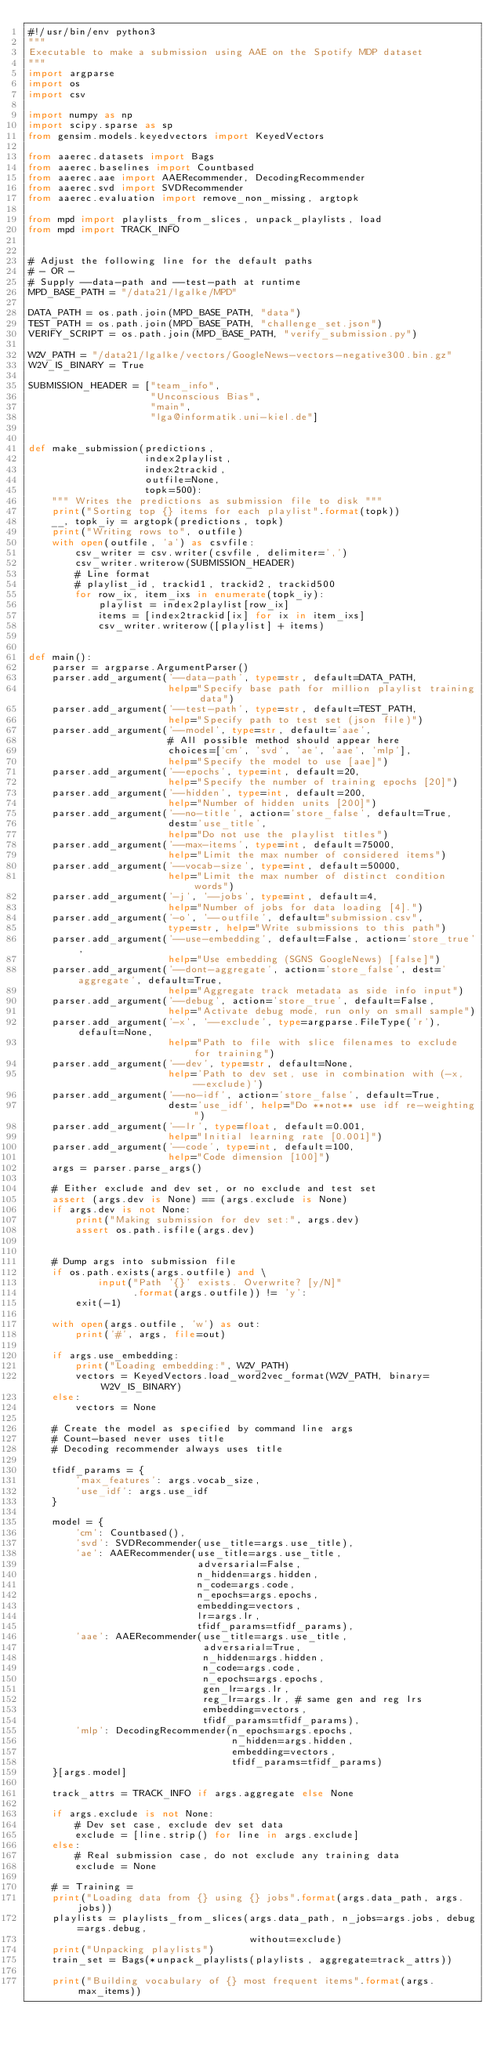<code> <loc_0><loc_0><loc_500><loc_500><_Python_>#!/usr/bin/env python3
"""
Executable to make a submission using AAE on the Spotify MDP dataset
"""
import argparse
import os
import csv

import numpy as np
import scipy.sparse as sp
from gensim.models.keyedvectors import KeyedVectors

from aaerec.datasets import Bags
from aaerec.baselines import Countbased
from aaerec.aae import AAERecommender, DecodingRecommender
from aaerec.svd import SVDRecommender
from aaerec.evaluation import remove_non_missing, argtopk

from mpd import playlists_from_slices, unpack_playlists, load
from mpd import TRACK_INFO


# Adjust the following line for the default paths
# - OR -
# Supply --data-path and --test-path at runtime
MPD_BASE_PATH = "/data21/lgalke/MPD"

DATA_PATH = os.path.join(MPD_BASE_PATH, "data")
TEST_PATH = os.path.join(MPD_BASE_PATH, "challenge_set.json")
VERIFY_SCRIPT = os.path.join(MPD_BASE_PATH, "verify_submission.py")

W2V_PATH = "/data21/lgalke/vectors/GoogleNews-vectors-negative300.bin.gz"
W2V_IS_BINARY = True

SUBMISSION_HEADER = ["team_info",
                     "Unconscious Bias",
                     "main",
                     "lga@informatik.uni-kiel.de"]


def make_submission(predictions,
                    index2playlist,
                    index2trackid,
                    outfile=None,
                    topk=500):
    """ Writes the predictions as submission file to disk """
    print("Sorting top {} items for each playlist".format(topk))
    __, topk_iy = argtopk(predictions, topk)
    print("Writing rows to", outfile)
    with open(outfile, 'a') as csvfile:
        csv_writer = csv.writer(csvfile, delimiter=',')
        csv_writer.writerow(SUBMISSION_HEADER)
        # Line format
        # playlist_id, trackid1, trackid2, trackid500
        for row_ix, item_ixs in enumerate(topk_iy):
            playlist = index2playlist[row_ix]
            items = [index2trackid[ix] for ix in item_ixs]
            csv_writer.writerow([playlist] + items)


def main():
    parser = argparse.ArgumentParser()
    parser.add_argument('--data-path', type=str, default=DATA_PATH,
                        help="Specify base path for million playlist training data")
    parser.add_argument('--test-path', type=str, default=TEST_PATH,
                        help="Specify path to test set (json file)")
    parser.add_argument('--model', type=str, default='aae',
                        # All possible method should appear here
                        choices=['cm', 'svd', 'ae', 'aae', 'mlp'],
                        help="Specify the model to use [aae]")
    parser.add_argument('--epochs', type=int, default=20,
                        help="Specify the number of training epochs [20]")
    parser.add_argument('--hidden', type=int, default=200,
                        help="Number of hidden units [200]")
    parser.add_argument('--no-title', action='store_false', default=True,
                        dest='use_title',
                        help="Do not use the playlist titles")
    parser.add_argument('--max-items', type=int, default=75000,
                        help="Limit the max number of considered items")
    parser.add_argument('--vocab-size', type=int, default=50000,
                        help="Limit the max number of distinct condition words")
    parser.add_argument('-j', '--jobs', type=int, default=4,
                        help="Number of jobs for data loading [4].")
    parser.add_argument('-o', '--outfile', default="submission.csv",
                        type=str, help="Write submissions to this path")
    parser.add_argument('--use-embedding', default=False, action='store_true',
                        help="Use embedding (SGNS GoogleNews) [false]")
    parser.add_argument('--dont-aggregate', action='store_false', dest='aggregate', default=True,
                        help="Aggregate track metadata as side info input")
    parser.add_argument('--debug', action='store_true', default=False,
                        help="Activate debug mode, run only on small sample")
    parser.add_argument('-x', '--exclude', type=argparse.FileType('r'),  default=None,
                        help="Path to file with slice filenames to exclude for training")
    parser.add_argument('--dev', type=str, default=None,
                        help='Path to dev set, use in combination with (-x, --exclude)')
    parser.add_argument('--no-idf', action='store_false', default=True,
                        dest='use_idf', help="Do **not** use idf re-weighting")
    parser.add_argument('--lr', type=float, default=0.001,
                        help="Initial learning rate [0.001]")
    parser.add_argument('--code', type=int, default=100,
                        help="Code dimension [100]")
    args = parser.parse_args()

    # Either exclude and dev set, or no exclude and test set
    assert (args.dev is None) == (args.exclude is None)
    if args.dev is not None:
        print("Making submission for dev set:", args.dev)
        assert os.path.isfile(args.dev)


    # Dump args into submission file
    if os.path.exists(args.outfile) and \
            input("Path '{}' exists. Overwrite? [y/N]"
                  .format(args.outfile)) != 'y':
        exit(-1)

    with open(args.outfile, 'w') as out:
        print('#', args, file=out)

    if args.use_embedding:
        print("Loading embedding:", W2V_PATH)
        vectors = KeyedVectors.load_word2vec_format(W2V_PATH, binary=W2V_IS_BINARY)
    else:
        vectors = None

    # Create the model as specified by command line args
    # Count-based never uses title
    # Decoding recommender always uses title

    tfidf_params = {
        'max_features': args.vocab_size,
        'use_idf': args.use_idf
    }

    model = {
        'cm': Countbased(),
        'svd': SVDRecommender(use_title=args.use_title),
        'ae': AAERecommender(use_title=args.use_title,
                             adversarial=False,
                             n_hidden=args.hidden,
                             n_code=args.code,
                             n_epochs=args.epochs,
                             embedding=vectors,
                             lr=args.lr,
                             tfidf_params=tfidf_params),
        'aae': AAERecommender(use_title=args.use_title,
                              adversarial=True,
                              n_hidden=args.hidden,
                              n_code=args.code,
                              n_epochs=args.epochs,
                              gen_lr=args.lr,
                              reg_lr=args.lr, # same gen and reg lrs
                              embedding=vectors,
                              tfidf_params=tfidf_params),
        'mlp': DecodingRecommender(n_epochs=args.epochs,
                                   n_hidden=args.hidden,
                                   embedding=vectors,
                                   tfidf_params=tfidf_params)
    }[args.model]

    track_attrs = TRACK_INFO if args.aggregate else None

    if args.exclude is not None:
        # Dev set case, exclude dev set data
        exclude = [line.strip() for line in args.exclude]
    else:
        # Real submission case, do not exclude any training data
        exclude = None

    # = Training =
    print("Loading data from {} using {} jobs".format(args.data_path, args.jobs))
    playlists = playlists_from_slices(args.data_path, n_jobs=args.jobs, debug=args.debug,
                                      without=exclude)
    print("Unpacking playlists")
    train_set = Bags(*unpack_playlists(playlists, aggregate=track_attrs))

    print("Building vocabulary of {} most frequent items".format(args.max_items))</code> 